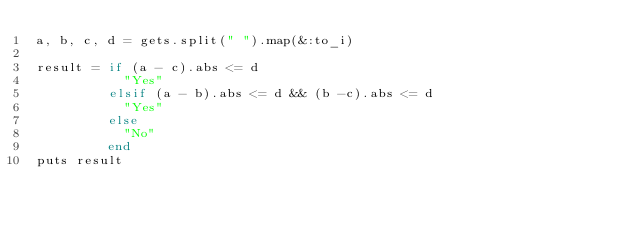<code> <loc_0><loc_0><loc_500><loc_500><_Ruby_>a, b, c, d = gets.split(" ").map(&:to_i)

result = if (a - c).abs <= d
           "Yes"
         elsif (a - b).abs <= d && (b -c).abs <= d
           "Yes"
         else
           "No"
         end
puts result</code> 